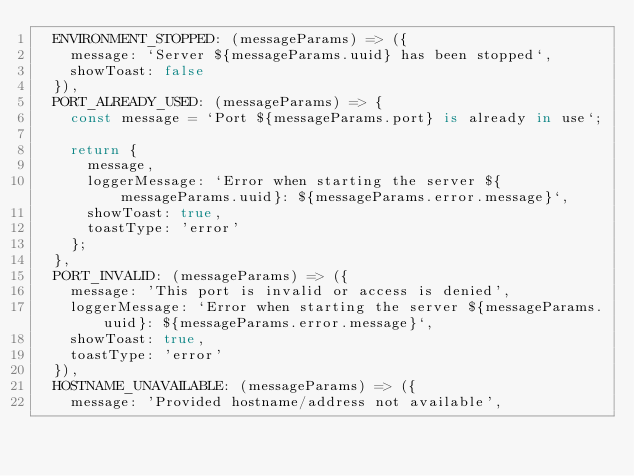<code> <loc_0><loc_0><loc_500><loc_500><_TypeScript_>  ENVIRONMENT_STOPPED: (messageParams) => ({
    message: `Server ${messageParams.uuid} has been stopped`,
    showToast: false
  }),
  PORT_ALREADY_USED: (messageParams) => {
    const message = `Port ${messageParams.port} is already in use`;

    return {
      message,
      loggerMessage: `Error when starting the server ${messageParams.uuid}: ${messageParams.error.message}`,
      showToast: true,
      toastType: 'error'
    };
  },
  PORT_INVALID: (messageParams) => ({
    message: 'This port is invalid or access is denied',
    loggerMessage: `Error when starting the server ${messageParams.uuid}: ${messageParams.error.message}`,
    showToast: true,
    toastType: 'error'
  }),
  HOSTNAME_UNAVAILABLE: (messageParams) => ({
    message: 'Provided hostname/address not available',</code> 